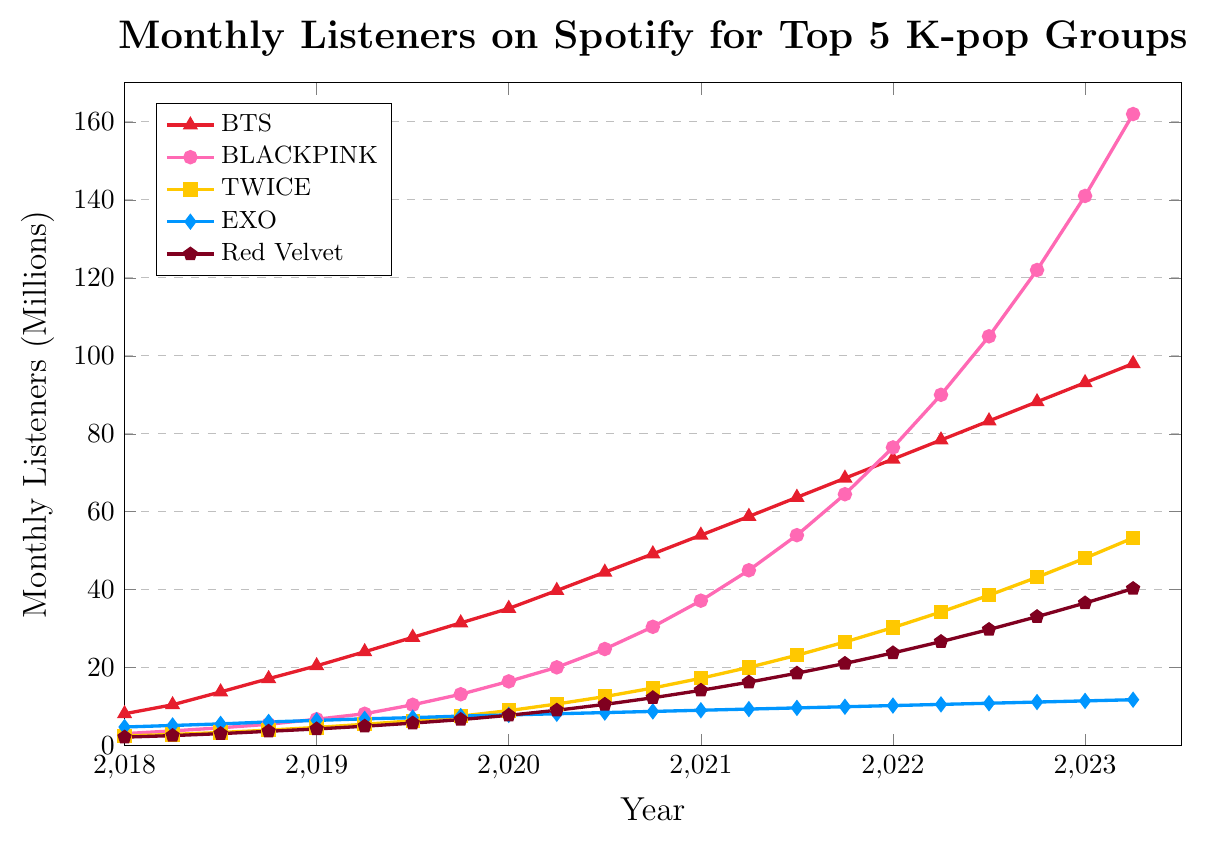What year did BLACKPINK surpass BTS in monthly listeners? Looking at the plot, BLACKPINK's line crosses above BTS's line between January 2022 and April 2022. Thus, the group exceeded BTS in monthly listeners after January 2022.
Answer: 2022 Which group had the lowest monthly listeners in January 2019? By examining the plot at January 2019, Red Velvet had the lowest position compared to the other groups.
Answer: Red Velvet What is the difference in monthly listeners between BLACKPINK and TWICE in April 2023? In April 2023, BLACKPINK had 162M listeners and TWICE had 53.3M listeners. The difference is 162 - 53.3 = 108.7M.
Answer: 108.7M What was EXO's trend in monthly listeners from 2020 to 2023? Observing EXO's line from 2020 to 2023 shows a gradual and steady increase in monthly listeners, though the group has smaller increases compared to others.
Answer: Steady increase Calculate the average monthly listeners for BTS in 2022. For the year 2022, BTS had monthly listener counts of 73.5M, 78.4M, 83.3M, and 88.2M. The average is calculated as (73.5 + 78.4 + 83.3 + 88.2)/4 = 323.4/4 = 80.85M.
Answer: 80.85M Which group saw the largest absolute increase in monthly listeners from 2018 to 2023? In 2018, BLACKPINK had 3.1M listeners, and in 2023, they had 162M listeners, amounting to an increase of 162 - 3.1 = 158.9M. Checking other groups: BTS had an increase of 98M - 8.2M = 89.8M, which is less. Therefore, BLACKPINK had the largest absolute increase.
Answer: BLACKPINK Using the visual attributes, which group is represented with a pentagon marker on the plot? By locating the group with a pentagon marker on the figure, we see that it correlates with Red Velvet.
Answer: Red Velvet Between January 2019 and January 2020, which group experienced the highest growth rate in monthly listeners? From January 2019 to January 2020, BLACKPINK grew from 6.8M to 16.5M, a growth of 16.5 - 6.8 = 9.7M. Checking other groups, BTS grew by 14.7M, TWICE by 4.3M, EXO by 1.4M, and Red Velvet by 3.5M. Thus, BLACKPINK had the highest growth rate.
Answer: BLACKPINK 